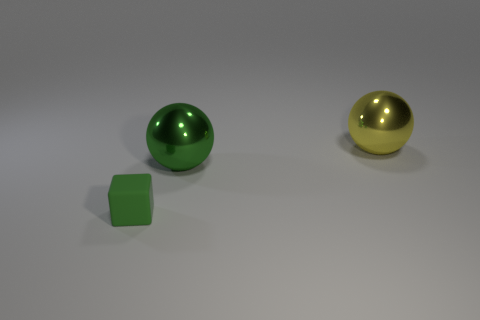What number of things are either small green metal balls or tiny blocks?
Provide a succinct answer. 1. Are there any other things that are made of the same material as the small green cube?
Keep it short and to the point. No. Are there any small red balls?
Offer a very short reply. No. Do the green thing that is right of the green block and the yellow sphere have the same material?
Your answer should be compact. Yes. Is there a green metal object that has the same shape as the yellow shiny object?
Keep it short and to the point. Yes. Are there an equal number of big yellow shiny balls behind the yellow shiny sphere and big green shiny cylinders?
Your answer should be compact. Yes. What material is the green object to the left of the large metallic thing that is in front of the big yellow metallic object?
Make the answer very short. Rubber. The big green metallic thing is what shape?
Offer a very short reply. Sphere. Is the number of cubes that are to the right of the small green rubber thing the same as the number of yellow objects in front of the green ball?
Offer a terse response. Yes. There is a large metallic object behind the large green ball; does it have the same color as the object to the left of the green metallic sphere?
Your response must be concise. No. 